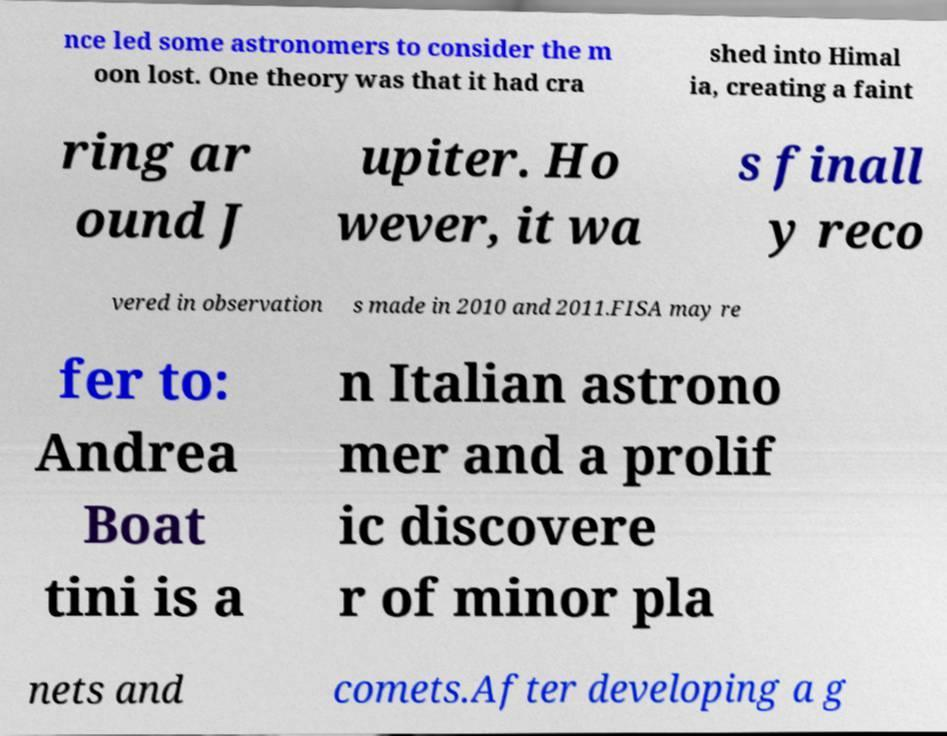Can you read and provide the text displayed in the image?This photo seems to have some interesting text. Can you extract and type it out for me? nce led some astronomers to consider the m oon lost. One theory was that it had cra shed into Himal ia, creating a faint ring ar ound J upiter. Ho wever, it wa s finall y reco vered in observation s made in 2010 and 2011.FISA may re fer to: Andrea Boat tini is a n Italian astrono mer and a prolif ic discovere r of minor pla nets and comets.After developing a g 